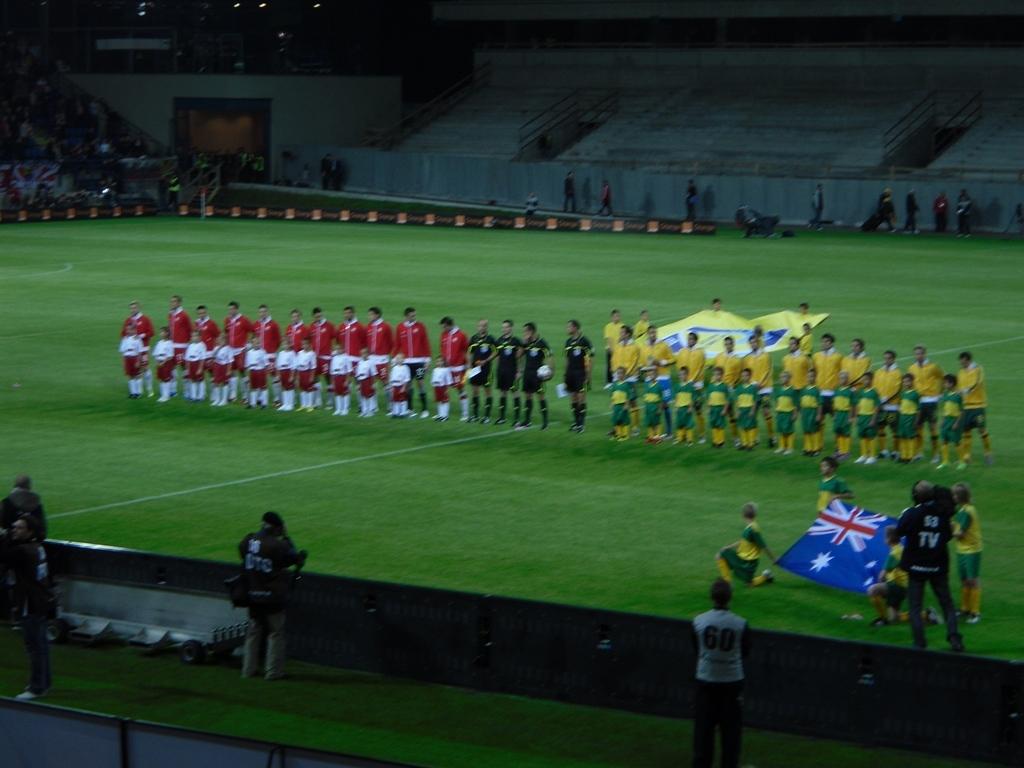What's on the tv crew shirts?
Give a very brief answer. Tv. 